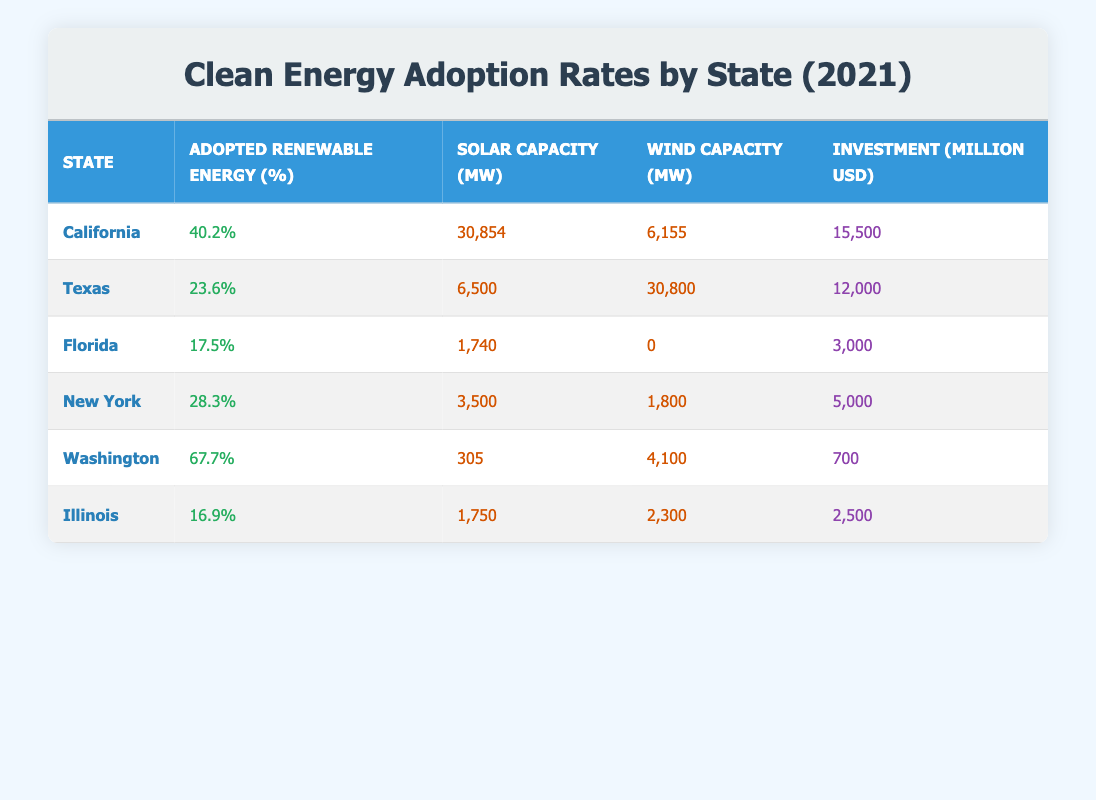What is the clean energy adoption percentage for Washington state? From the table, Washington has an adopted renewable energy percent listed as 67.7%, which is the data provided.
Answer: 67.7% Which state has the highest solar capacity? Looking at the solar capacity column, California has the highest solar capacity listed at 30,854 MW.
Answer: California What is the difference in wind capacity between Texas and Florida? Texas has a wind capacity of 30,800 MW and Florida has 0 MW. The difference is 30,800 - 0 = 30,800 MW.
Answer: 30,800 MW Is it true that Illinois has a higher investment in clean energy compared to Florida? Illinois has an investment of 2,500 million USD, while Florida's investment is 3,000 million USD. Therefore, this statement is false.
Answer: No What is the average percentage of adopted renewable energy across the six states in the table? The total adoption percentages are 40.2 + 23.6 + 17.5 + 28.3 + 67.7 + 16.9 = 194.2. There are 6 states, so the average is 194.2 / 6 = 32.37%.
Answer: 32.37% Which state shows more total renewable capacity when combining solar and wind? For the total renewable capacity, add solar and wind for each state: California (30,854 + 6,155 = 37,009), Texas (6,500 + 30,800 = 37,300), Florida (1,740 + 0 = 1,740), New York (3,500 + 1,800 = 5,300), Washington (305 + 4,100 = 4,405), Illinois (1,750 + 2,300 = 4,050). Texas has the highest total at 37,300 MW.
Answer: Texas How much investment is made in clean energy for the state with the lowest adoption percentage? Illinois has the lowest adoption percentage at 16.9% and the investment listed is 2,500 million USD.
Answer: 2,500 million USD What is the total investment made in clean energy across all states? Summing the investments: 15,500 + 12,000 + 3,000 + 5,000 + 700 + 2,500 = 38,700 million USD.
Answer: 38,700 million USD Is New York's adopted renewable energy percentage higher than Texas'? New York's percentage is 28.3% whereas Texas' is 23.6%. Therefore, New York's is higher, making this statement true.
Answer: Yes 